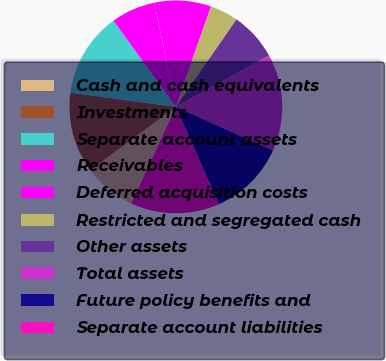Convert chart to OTSL. <chart><loc_0><loc_0><loc_500><loc_500><pie_chart><fcel>Cash and cash equivalents<fcel>Investments<fcel>Separate account assets<fcel>Receivables<fcel>Deferred acquisition costs<fcel>Restricted and segregated cash<fcel>Other assets<fcel>Total assets<fcel>Future policy benefits and<fcel>Separate account liabilities<nl><fcel>7.98%<fcel>12.27%<fcel>12.88%<fcel>6.75%<fcel>8.59%<fcel>4.29%<fcel>7.36%<fcel>14.72%<fcel>11.66%<fcel>13.5%<nl></chart> 